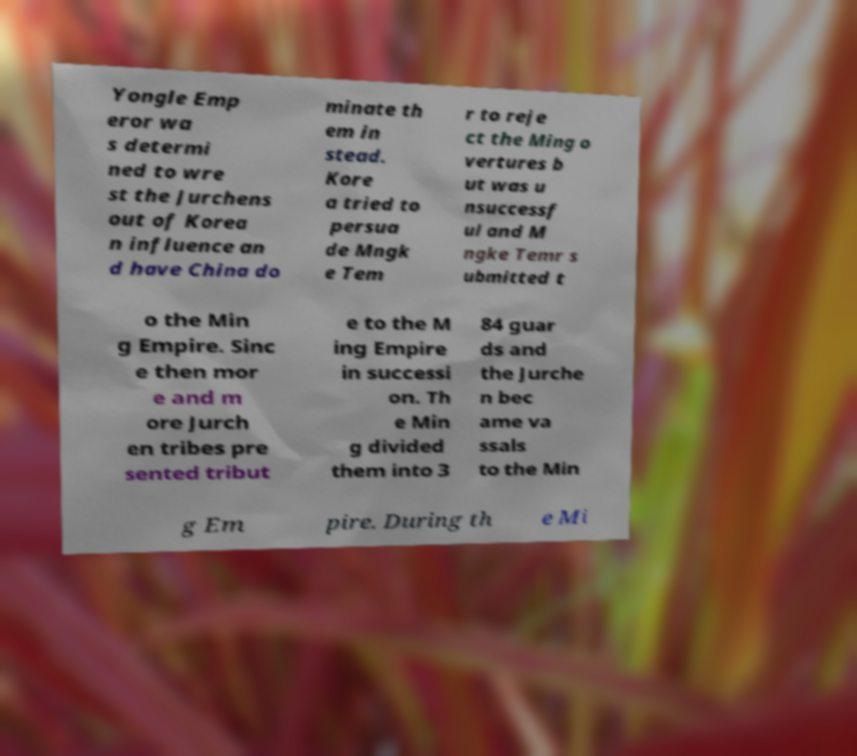Could you assist in decoding the text presented in this image and type it out clearly? Yongle Emp eror wa s determi ned to wre st the Jurchens out of Korea n influence an d have China do minate th em in stead. Kore a tried to persua de Mngk e Tem r to reje ct the Ming o vertures b ut was u nsuccessf ul and M ngke Temr s ubmitted t o the Min g Empire. Sinc e then mor e and m ore Jurch en tribes pre sented tribut e to the M ing Empire in successi on. Th e Min g divided them into 3 84 guar ds and the Jurche n bec ame va ssals to the Min g Em pire. During th e Mi 